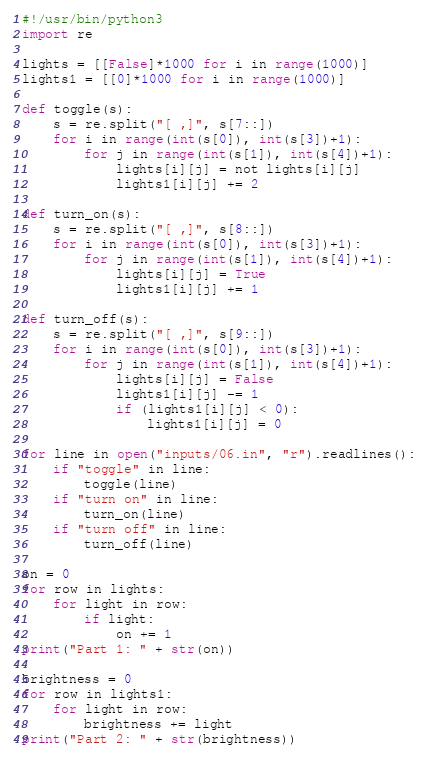Convert code to text. <code><loc_0><loc_0><loc_500><loc_500><_Python_>#!/usr/bin/python3
import re

lights = [[False]*1000 for i in range(1000)]
lights1 = [[0]*1000 for i in range(1000)]

def toggle(s):
    s = re.split("[ ,]", s[7::])
    for i in range(int(s[0]), int(s[3])+1):
        for j in range(int(s[1]), int(s[4])+1):
            lights[i][j] = not lights[i][j]
            lights1[i][j] += 2

def turn_on(s):
    s = re.split("[ ,]", s[8::])
    for i in range(int(s[0]), int(s[3])+1):
        for j in range(int(s[1]), int(s[4])+1):
            lights[i][j] = True
            lights1[i][j] += 1

def turn_off(s):
    s = re.split("[ ,]", s[9::])
    for i in range(int(s[0]), int(s[3])+1):
        for j in range(int(s[1]), int(s[4])+1):
            lights[i][j] = False
            lights1[i][j] -= 1
            if (lights1[i][j] < 0):
                lights1[i][j] = 0

for line in open("inputs/06.in", "r").readlines():
    if "toggle" in line:
        toggle(line)
    if "turn on" in line:
        turn_on(line)
    if "turn off" in line:
        turn_off(line)

on = 0
for row in lights:
    for light in row:
        if light:
            on += 1
print("Part 1: " + str(on))

brightness = 0
for row in lights1:
    for light in row:
        brightness += light
print("Part 2: " + str(brightness))
</code> 